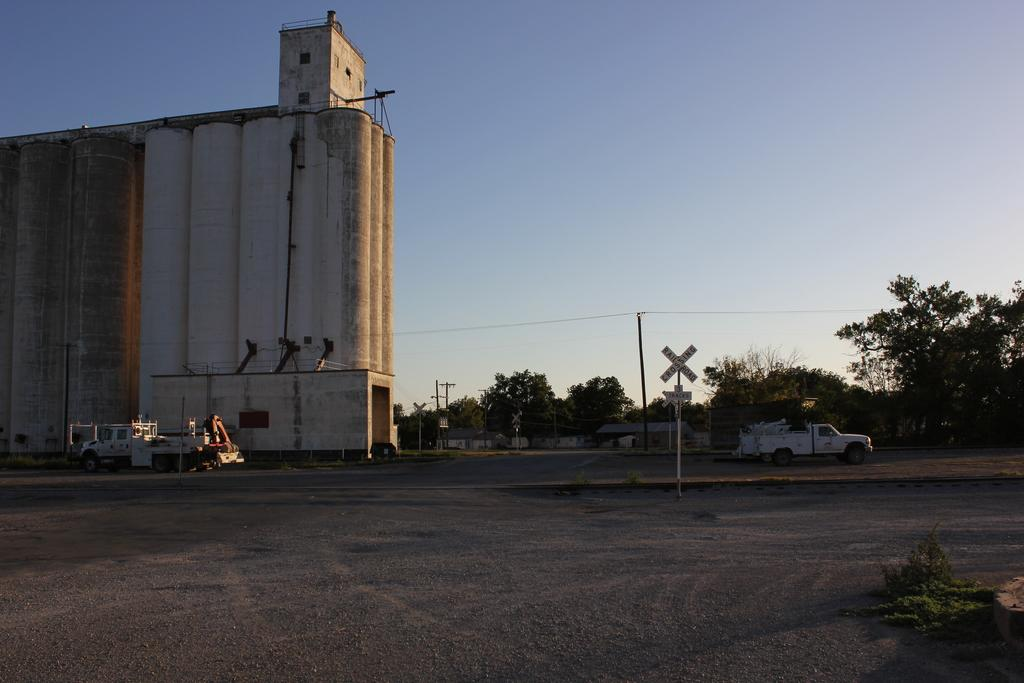What can be seen on the road in the image? There are vehicles on the road in the image. What structures are present in the image? There are poles, houses, and a building in the image. What type of vegetation is visible in the image? There are plants and trees in the image. What is visible in the background of the image? The sky is visible in the background of the image. Where is the steam coming from in the image? There is no steam present in the image. What type of stone can be seen in the image? There is no stone present in the image. 